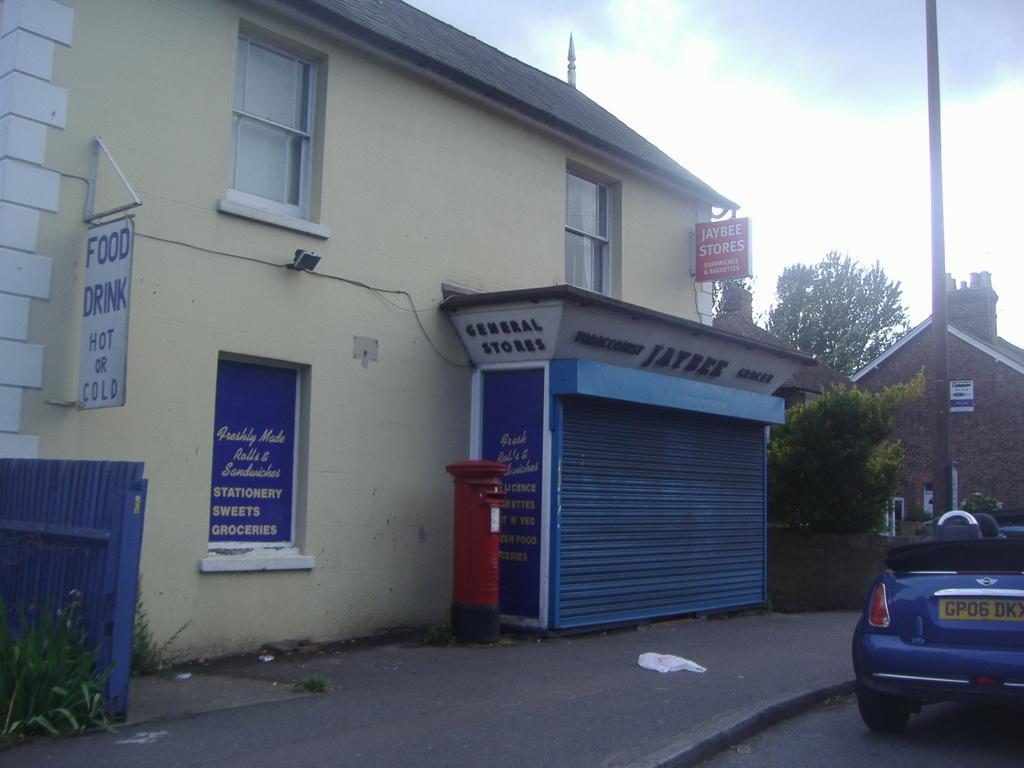Please provide a concise description of this image. Sky is cloudy. This is a building with roof top and with windows. In-front of this building there is a store. This is a postbox in red color. The fence is in blue color. Beside this fence there are plants. Far there is a house. This is pole. A vehicle on road. This vehicle is in blue color. Far there are trees. 